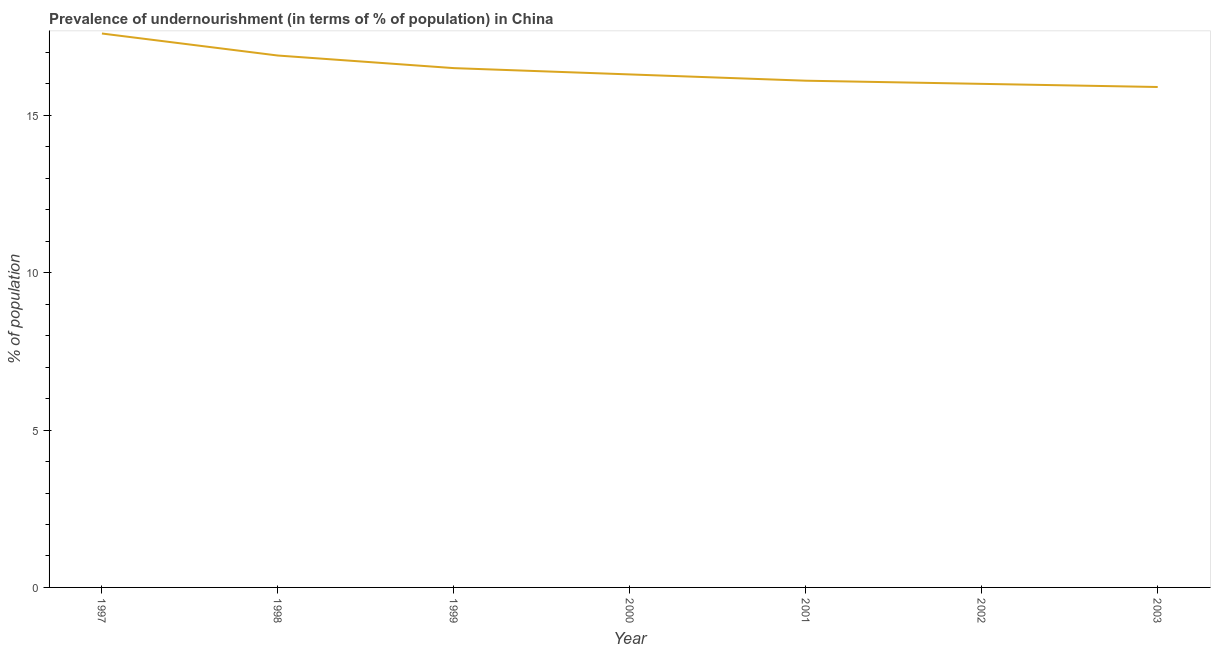Across all years, what is the maximum percentage of undernourished population?
Keep it short and to the point. 17.6. In which year was the percentage of undernourished population minimum?
Make the answer very short. 2003. What is the sum of the percentage of undernourished population?
Give a very brief answer. 115.3. What is the difference between the percentage of undernourished population in 2002 and 2003?
Your answer should be compact. 0.1. What is the average percentage of undernourished population per year?
Give a very brief answer. 16.47. What is the median percentage of undernourished population?
Make the answer very short. 16.3. Do a majority of the years between 2001 and 1997 (inclusive) have percentage of undernourished population greater than 12 %?
Make the answer very short. Yes. What is the ratio of the percentage of undernourished population in 1998 to that in 2003?
Give a very brief answer. 1.06. Is the percentage of undernourished population in 1998 less than that in 2000?
Offer a terse response. No. What is the difference between the highest and the second highest percentage of undernourished population?
Your answer should be very brief. 0.7. Is the sum of the percentage of undernourished population in 2000 and 2001 greater than the maximum percentage of undernourished population across all years?
Provide a short and direct response. Yes. What is the difference between the highest and the lowest percentage of undernourished population?
Offer a very short reply. 1.7. In how many years, is the percentage of undernourished population greater than the average percentage of undernourished population taken over all years?
Make the answer very short. 3. Does the percentage of undernourished population monotonically increase over the years?
Offer a very short reply. No. What is the difference between two consecutive major ticks on the Y-axis?
Make the answer very short. 5. Does the graph contain any zero values?
Provide a succinct answer. No. Does the graph contain grids?
Make the answer very short. No. What is the title of the graph?
Your answer should be compact. Prevalence of undernourishment (in terms of % of population) in China. What is the label or title of the Y-axis?
Offer a very short reply. % of population. What is the % of population in 1998?
Your answer should be compact. 16.9. What is the % of population in 1999?
Offer a very short reply. 16.5. What is the % of population of 2003?
Provide a short and direct response. 15.9. What is the difference between the % of population in 1997 and 1998?
Your answer should be very brief. 0.7. What is the difference between the % of population in 1998 and 1999?
Give a very brief answer. 0.4. What is the difference between the % of population in 1998 and 2000?
Offer a very short reply. 0.6. What is the difference between the % of population in 1998 and 2001?
Your response must be concise. 0.8. What is the difference between the % of population in 1998 and 2002?
Offer a terse response. 0.9. What is the difference between the % of population in 1999 and 2000?
Your response must be concise. 0.2. What is the difference between the % of population in 1999 and 2001?
Offer a terse response. 0.4. What is the difference between the % of population in 1999 and 2002?
Offer a terse response. 0.5. What is the difference between the % of population in 2000 and 2001?
Offer a terse response. 0.2. What is the difference between the % of population in 2000 and 2002?
Your answer should be compact. 0.3. What is the difference between the % of population in 2000 and 2003?
Offer a very short reply. 0.4. What is the difference between the % of population in 2001 and 2002?
Your answer should be very brief. 0.1. What is the difference between the % of population in 2002 and 2003?
Your answer should be compact. 0.1. What is the ratio of the % of population in 1997 to that in 1998?
Give a very brief answer. 1.04. What is the ratio of the % of population in 1997 to that in 1999?
Make the answer very short. 1.07. What is the ratio of the % of population in 1997 to that in 2000?
Provide a succinct answer. 1.08. What is the ratio of the % of population in 1997 to that in 2001?
Offer a very short reply. 1.09. What is the ratio of the % of population in 1997 to that in 2002?
Offer a terse response. 1.1. What is the ratio of the % of population in 1997 to that in 2003?
Give a very brief answer. 1.11. What is the ratio of the % of population in 1998 to that in 1999?
Your answer should be compact. 1.02. What is the ratio of the % of population in 1998 to that in 2002?
Ensure brevity in your answer.  1.06. What is the ratio of the % of population in 1998 to that in 2003?
Your answer should be compact. 1.06. What is the ratio of the % of population in 1999 to that in 2002?
Provide a succinct answer. 1.03. What is the ratio of the % of population in 1999 to that in 2003?
Offer a very short reply. 1.04. What is the ratio of the % of population in 2000 to that in 2003?
Provide a succinct answer. 1.02. 